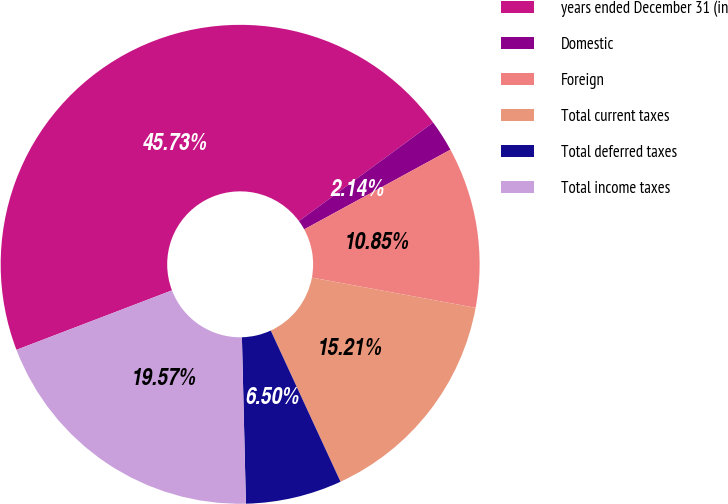<chart> <loc_0><loc_0><loc_500><loc_500><pie_chart><fcel>years ended December 31 (in<fcel>Domestic<fcel>Foreign<fcel>Total current taxes<fcel>Total deferred taxes<fcel>Total income taxes<nl><fcel>45.73%<fcel>2.14%<fcel>10.85%<fcel>15.21%<fcel>6.5%<fcel>19.57%<nl></chart> 